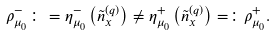<formula> <loc_0><loc_0><loc_500><loc_500>\rho _ { \mu _ { 0 } } ^ { - } \colon = \eta _ { \mu _ { 0 } } ^ { - } \left ( { \tilde { n } } _ { x } ^ { ( q ) } \right ) \ne \eta _ { \mu _ { 0 } } ^ { + } \left ( { \tilde { n } } _ { x } ^ { ( q ) } \right ) = \colon \rho _ { \mu _ { 0 } } ^ { + } .</formula> 